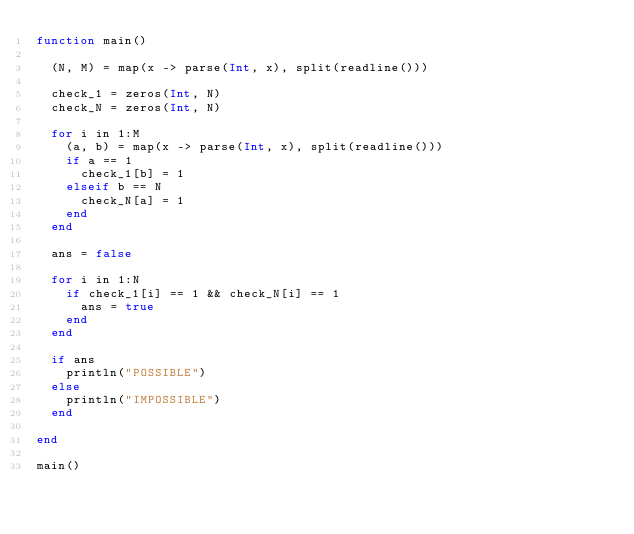Convert code to text. <code><loc_0><loc_0><loc_500><loc_500><_Julia_>function main()
  
  (N, M) = map(x -> parse(Int, x), split(readline()))

  check_1 = zeros(Int, N)
  check_N = zeros(Int, N)
  
  for i in 1:M
    (a, b) = map(x -> parse(Int, x), split(readline()))
    if a == 1
      check_1[b] = 1
    elseif b == N
      check_N[a] = 1
    end
  end
  
  ans = false
  
  for i in 1:N
    if check_1[i] == 1 && check_N[i] == 1
      ans = true
    end
  end  
  
  if ans
    println("POSSIBLE")
  else
    println("IMPOSSIBLE")
  end
  
end

main()</code> 